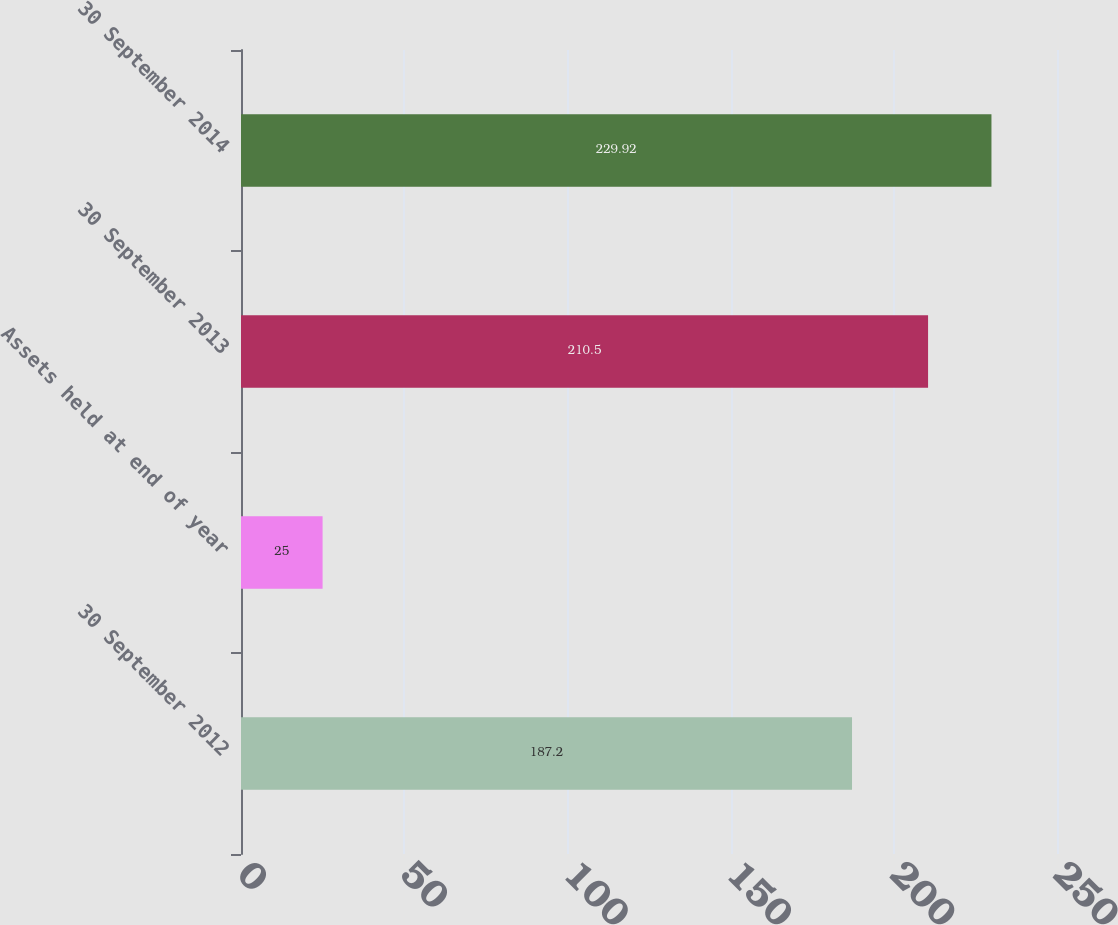Convert chart. <chart><loc_0><loc_0><loc_500><loc_500><bar_chart><fcel>30 September 2012<fcel>Assets held at end of year<fcel>30 September 2013<fcel>30 September 2014<nl><fcel>187.2<fcel>25<fcel>210.5<fcel>229.92<nl></chart> 